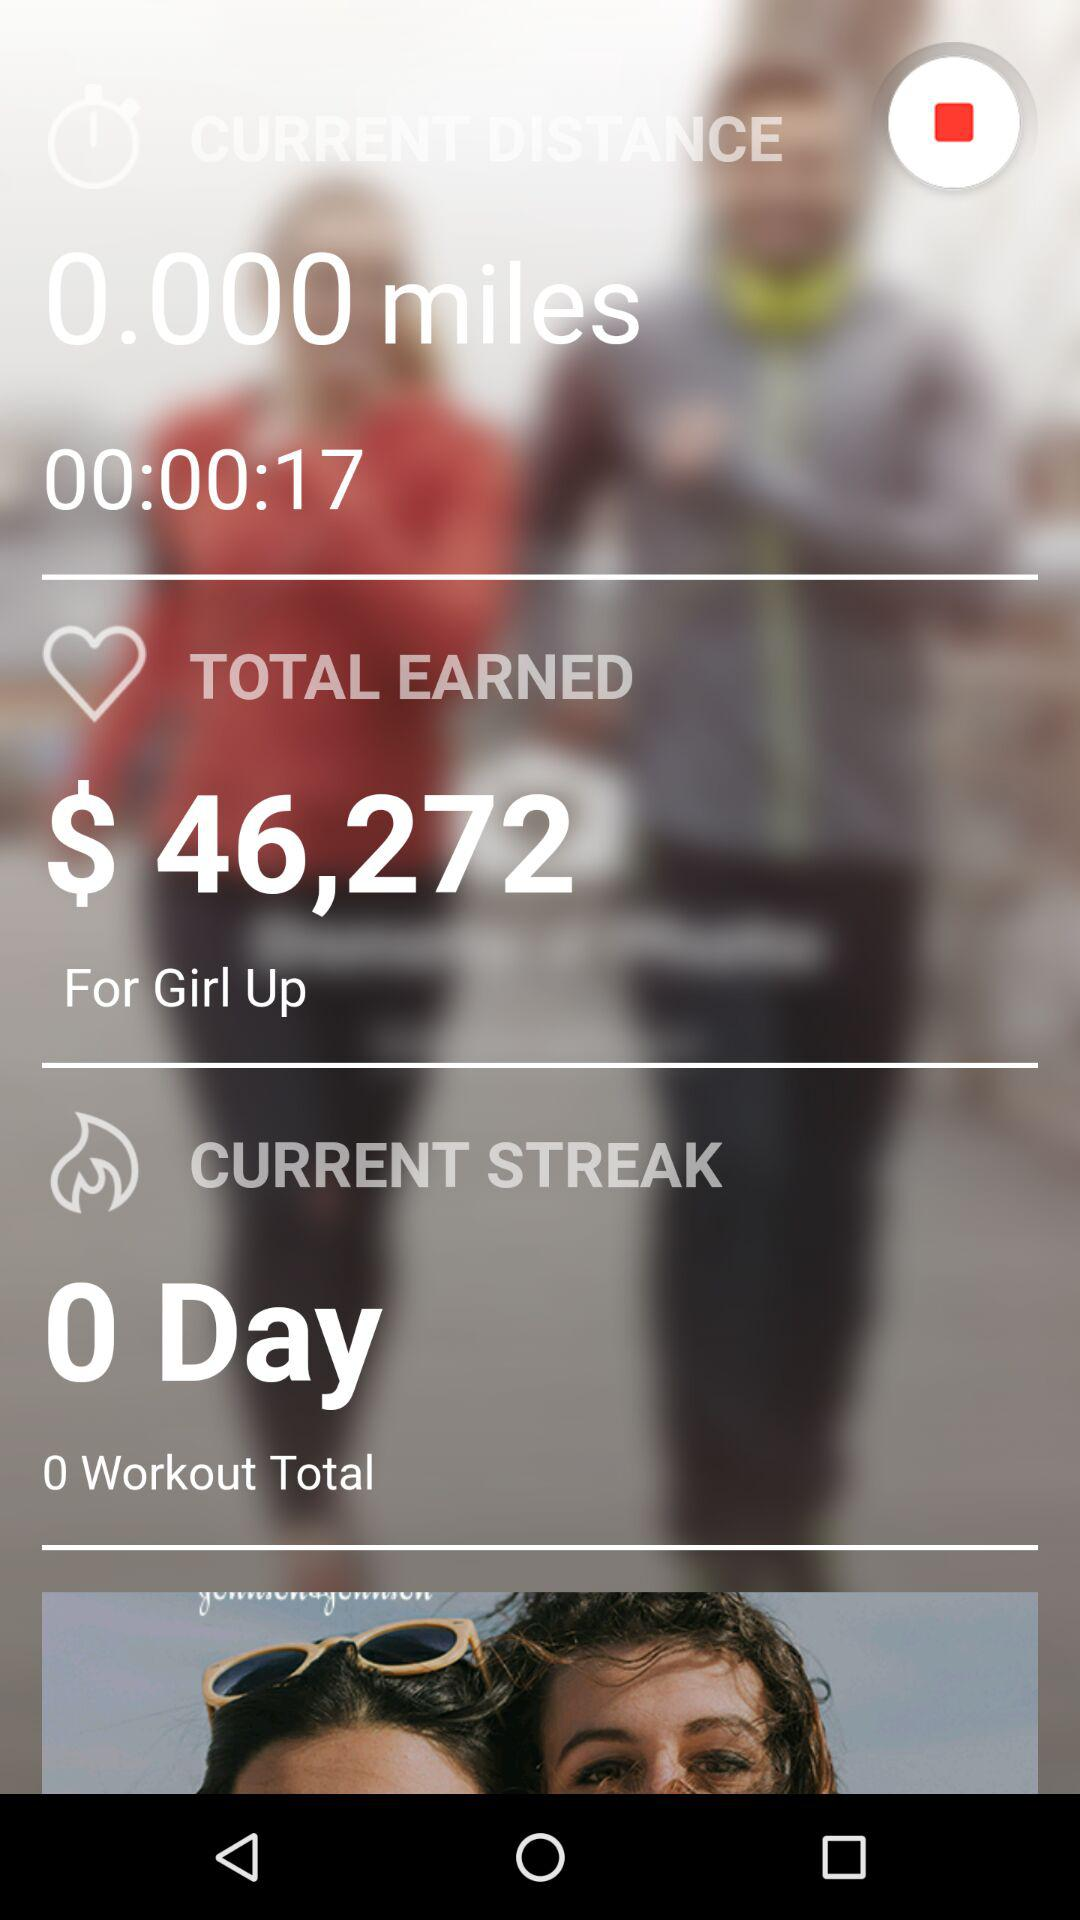What is the current distance? The current distance is 0 miles. 